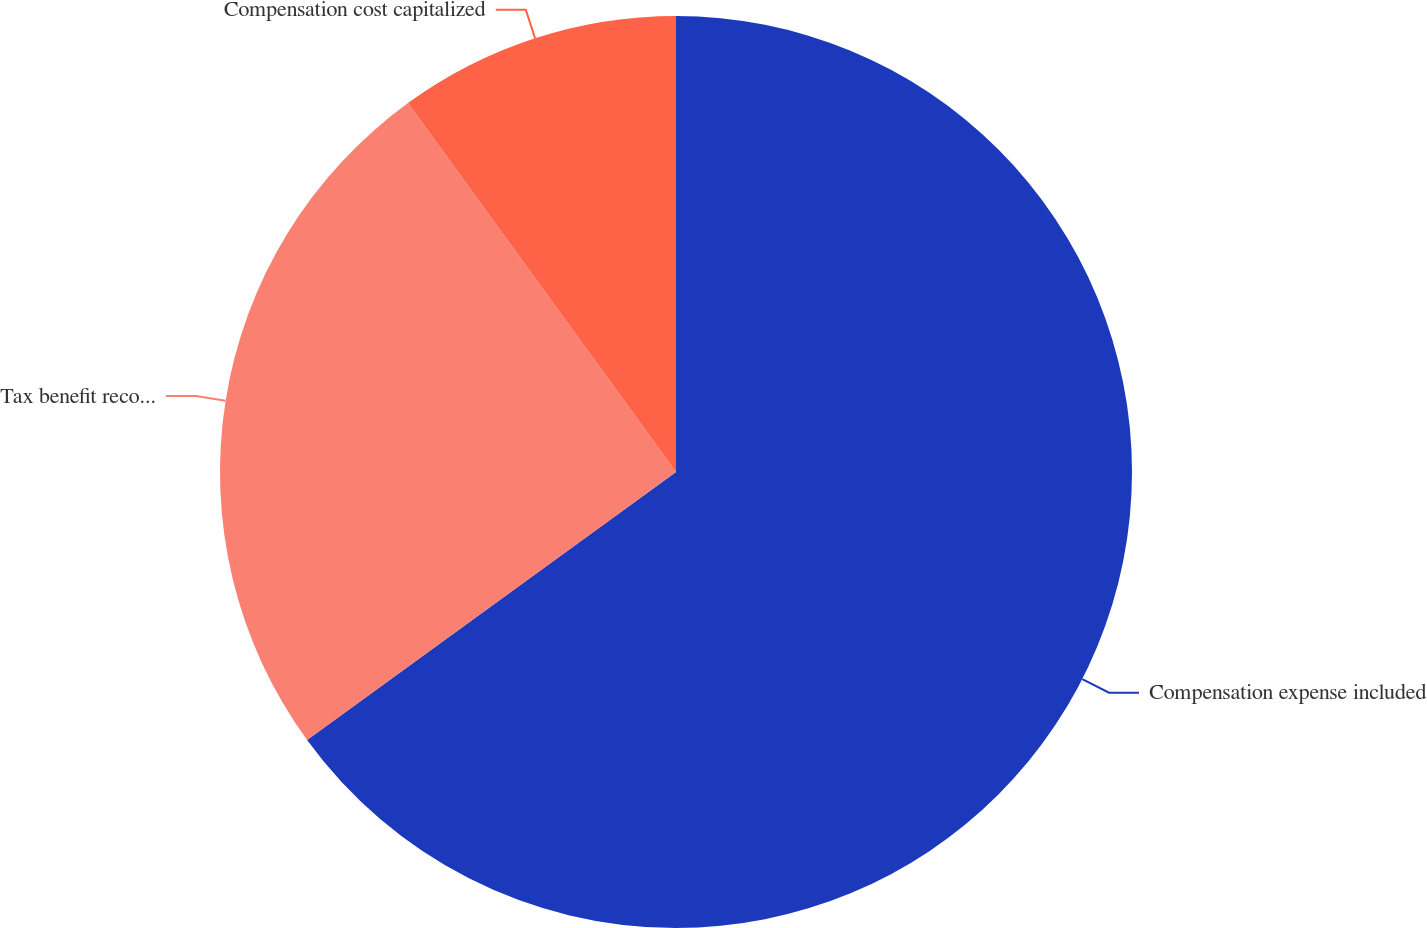Convert chart. <chart><loc_0><loc_0><loc_500><loc_500><pie_chart><fcel>Compensation expense included<fcel>Tax benefit recognized in<fcel>Compensation cost capitalized<nl><fcel>65.0%<fcel>25.0%<fcel>10.0%<nl></chart> 